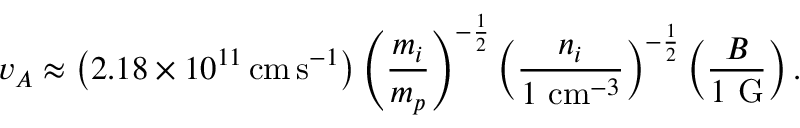<formula> <loc_0><loc_0><loc_500><loc_500>v _ { A } \approx \left ( 2 . 1 8 \times 1 0 ^ { 1 1 } \, { c m } \, { s } ^ { - 1 } \right ) \left ( { \frac { m _ { i } } { m _ { p } } } \right ) ^ { - { \frac { 1 } { 2 } } } \left ( { \frac { n _ { i } } { 1 { c m } ^ { - 3 } } } \right ) ^ { - { \frac { 1 } { 2 } } } \left ( { \frac { B } { 1 { G } } } \right ) .</formula> 